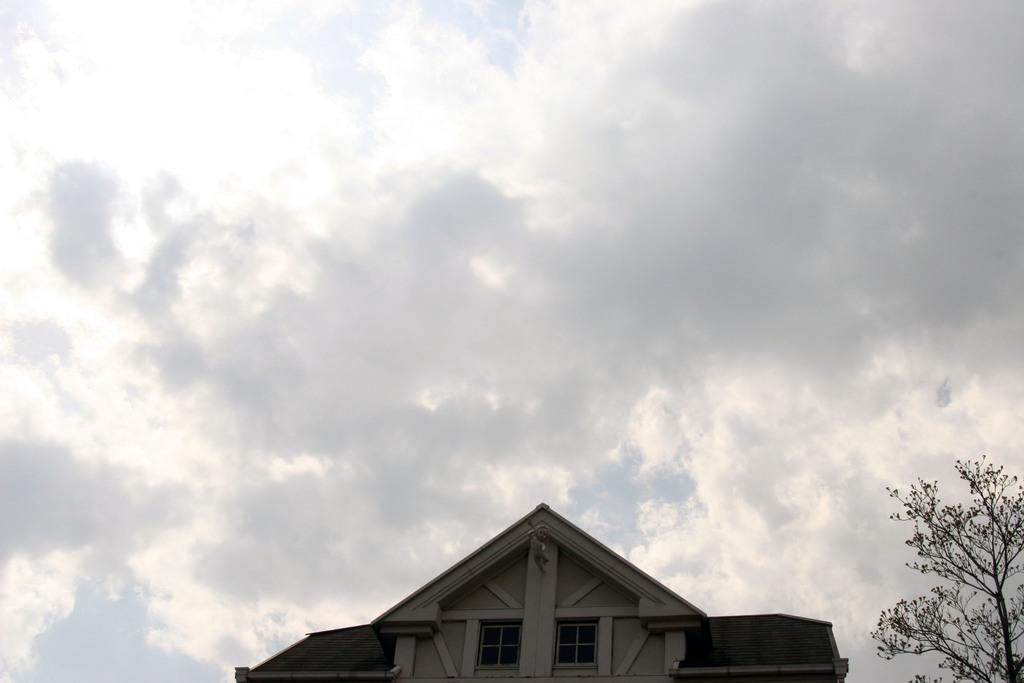What type of structure is located in the foreground of the image? There is a house in the foreground of the image. Where is the house positioned in relation to the image? The house is on the bottom side of the image. What type of vegetation can be seen on the right side of the image? There is a tree on the right side of the image. What is visible at the top of the image? Clouds and the sky are visible at the top of the image. Can you see a farmer tending to the tree in the image? There is no farmer present in the image. How many ladybugs are crawling on the house in the image? There are no ladybugs visible on the house in the image. 